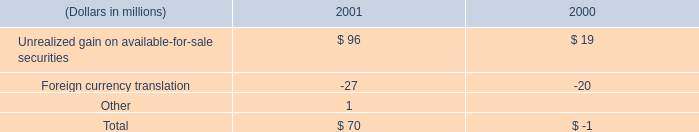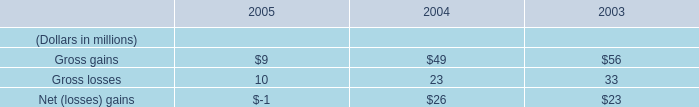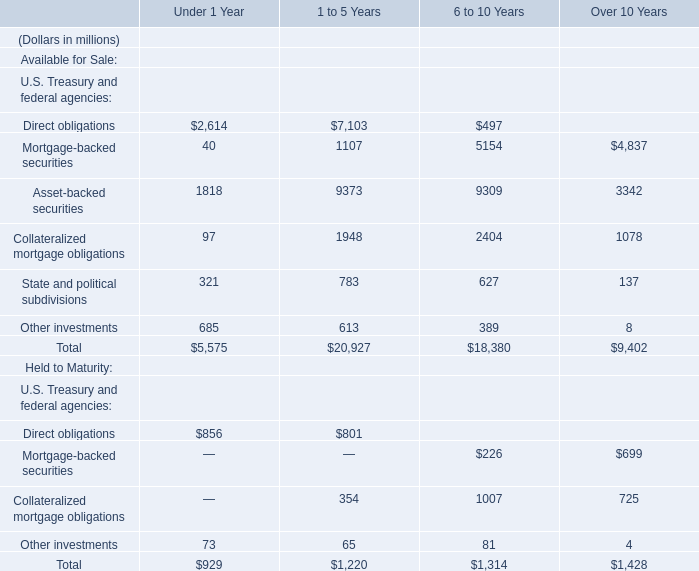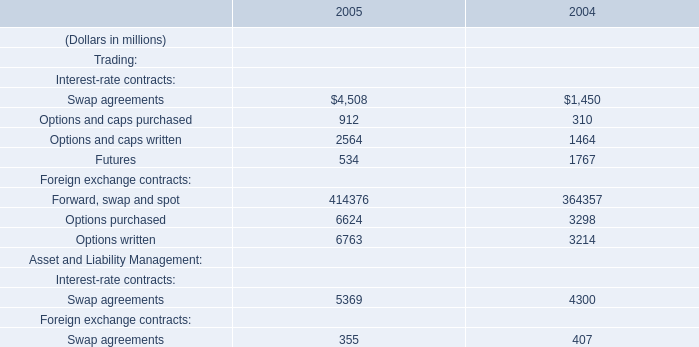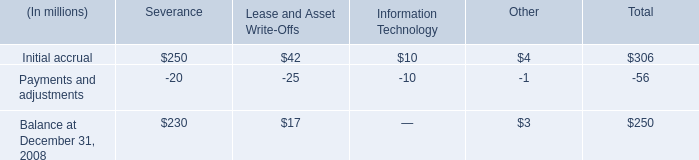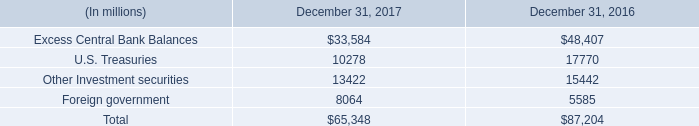in 2001 , what percent of gains were lost in foreign currency translation 
Computations: (27 / (96 + 1))
Answer: 0.27835. 